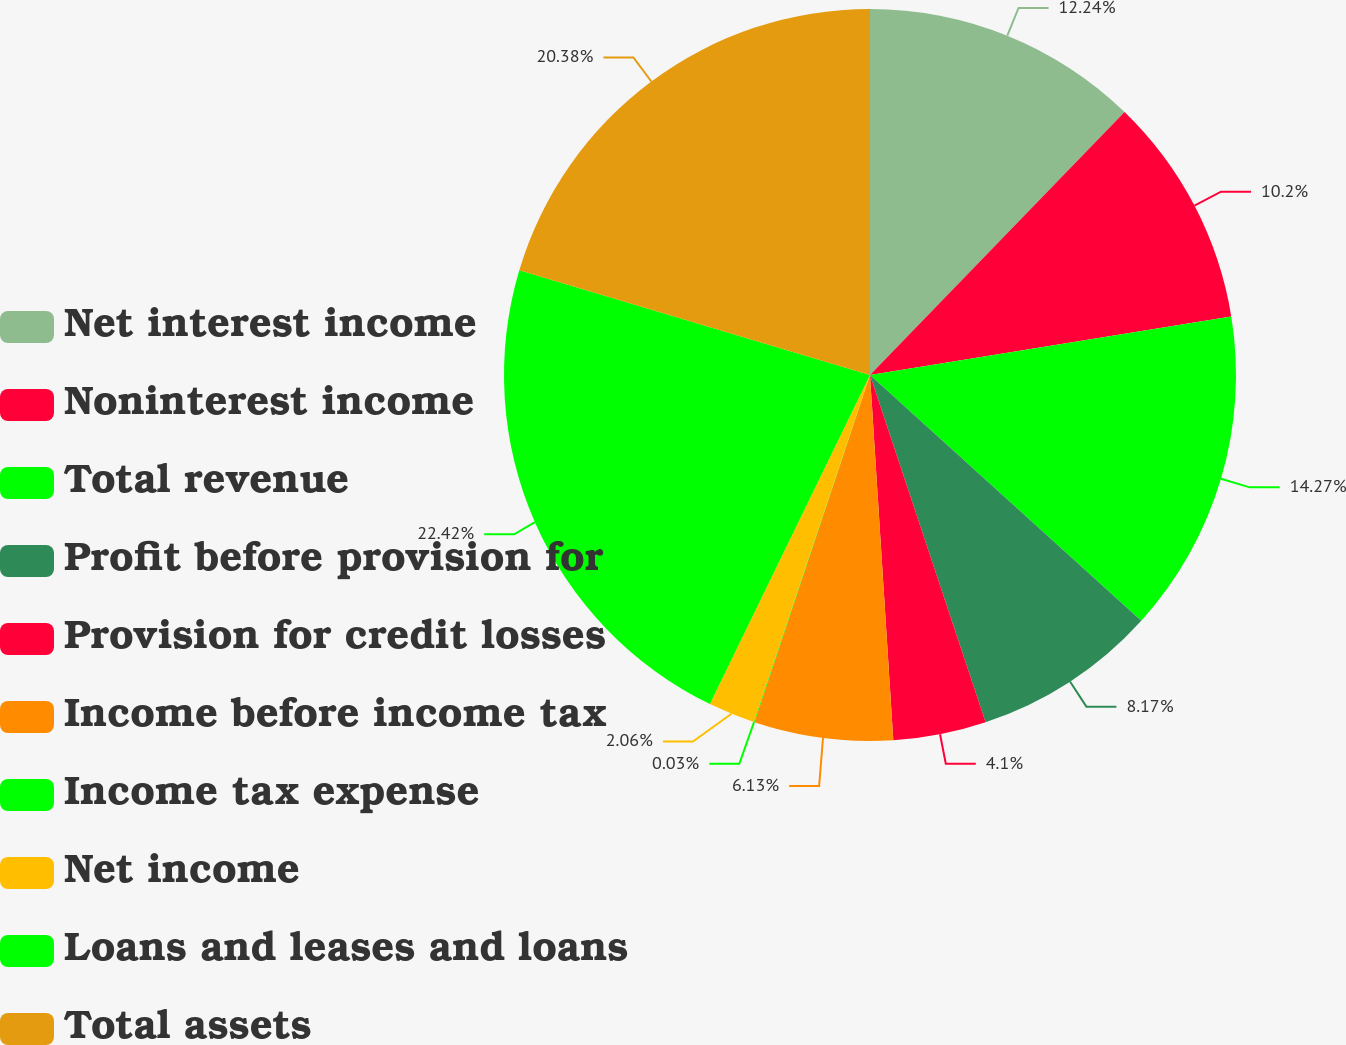Convert chart. <chart><loc_0><loc_0><loc_500><loc_500><pie_chart><fcel>Net interest income<fcel>Noninterest income<fcel>Total revenue<fcel>Profit before provision for<fcel>Provision for credit losses<fcel>Income before income tax<fcel>Income tax expense<fcel>Net income<fcel>Loans and leases and loans<fcel>Total assets<nl><fcel>12.24%<fcel>10.2%<fcel>14.27%<fcel>8.17%<fcel>4.1%<fcel>6.13%<fcel>0.03%<fcel>2.06%<fcel>22.41%<fcel>20.38%<nl></chart> 